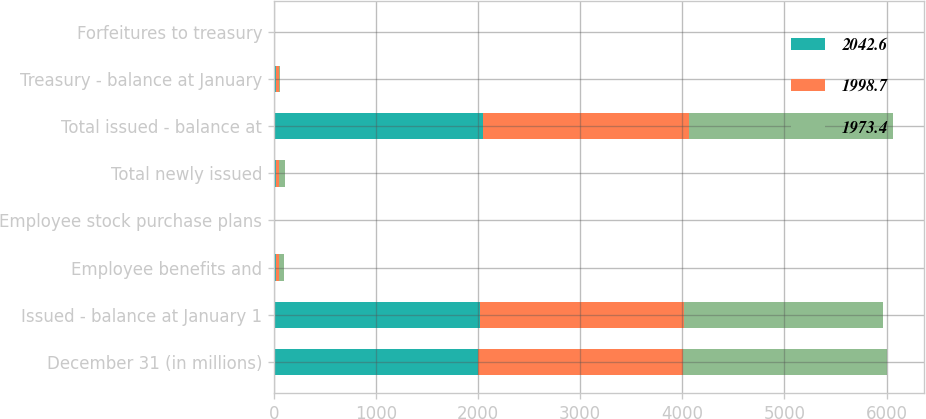Convert chart. <chart><loc_0><loc_0><loc_500><loc_500><stacked_bar_chart><ecel><fcel>December 31 (in millions)<fcel>Issued - balance at January 1<fcel>Employee benefits and<fcel>Employee stock purchase plans<fcel>Total newly issued<fcel>Total issued - balance at<fcel>Treasury - balance at January<fcel>Forfeitures to treasury<nl><fcel>2042.6<fcel>2003<fcel>2023.6<fcel>20.9<fcel>0.7<fcel>21.6<fcel>2044.4<fcel>24.9<fcel>3<nl><fcel>1998.7<fcel>2002<fcel>1996.9<fcel>25.9<fcel>0.8<fcel>26.7<fcel>2023.6<fcel>23.5<fcel>3.9<nl><fcel>1973.4<fcel>2001<fcel>1940.1<fcel>55<fcel>0.5<fcel>57.3<fcel>1996.9<fcel>11.6<fcel>5.8<nl></chart> 